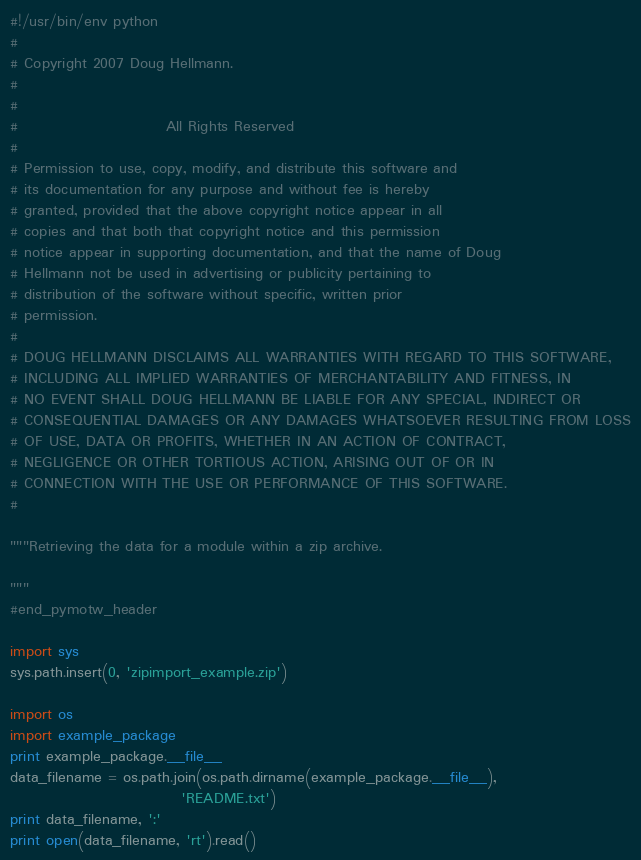Convert code to text. <code><loc_0><loc_0><loc_500><loc_500><_Python_>#!/usr/bin/env python
#
# Copyright 2007 Doug Hellmann.
#
#
#                         All Rights Reserved
#
# Permission to use, copy, modify, and distribute this software and
# its documentation for any purpose and without fee is hereby
# granted, provided that the above copyright notice appear in all
# copies and that both that copyright notice and this permission
# notice appear in supporting documentation, and that the name of Doug
# Hellmann not be used in advertising or publicity pertaining to
# distribution of the software without specific, written prior
# permission.
#
# DOUG HELLMANN DISCLAIMS ALL WARRANTIES WITH REGARD TO THIS SOFTWARE,
# INCLUDING ALL IMPLIED WARRANTIES OF MERCHANTABILITY AND FITNESS, IN
# NO EVENT SHALL DOUG HELLMANN BE LIABLE FOR ANY SPECIAL, INDIRECT OR
# CONSEQUENTIAL DAMAGES OR ANY DAMAGES WHATSOEVER RESULTING FROM LOSS
# OF USE, DATA OR PROFITS, WHETHER IN AN ACTION OF CONTRACT,
# NEGLIGENCE OR OTHER TORTIOUS ACTION, ARISING OUT OF OR IN
# CONNECTION WITH THE USE OR PERFORMANCE OF THIS SOFTWARE.
#

"""Retrieving the data for a module within a zip archive.

"""
#end_pymotw_header

import sys
sys.path.insert(0, 'zipimport_example.zip')

import os
import example_package
print example_package.__file__
data_filename = os.path.join(os.path.dirname(example_package.__file__), 
                             'README.txt')
print data_filename, ':'
print open(data_filename, 'rt').read()
</code> 